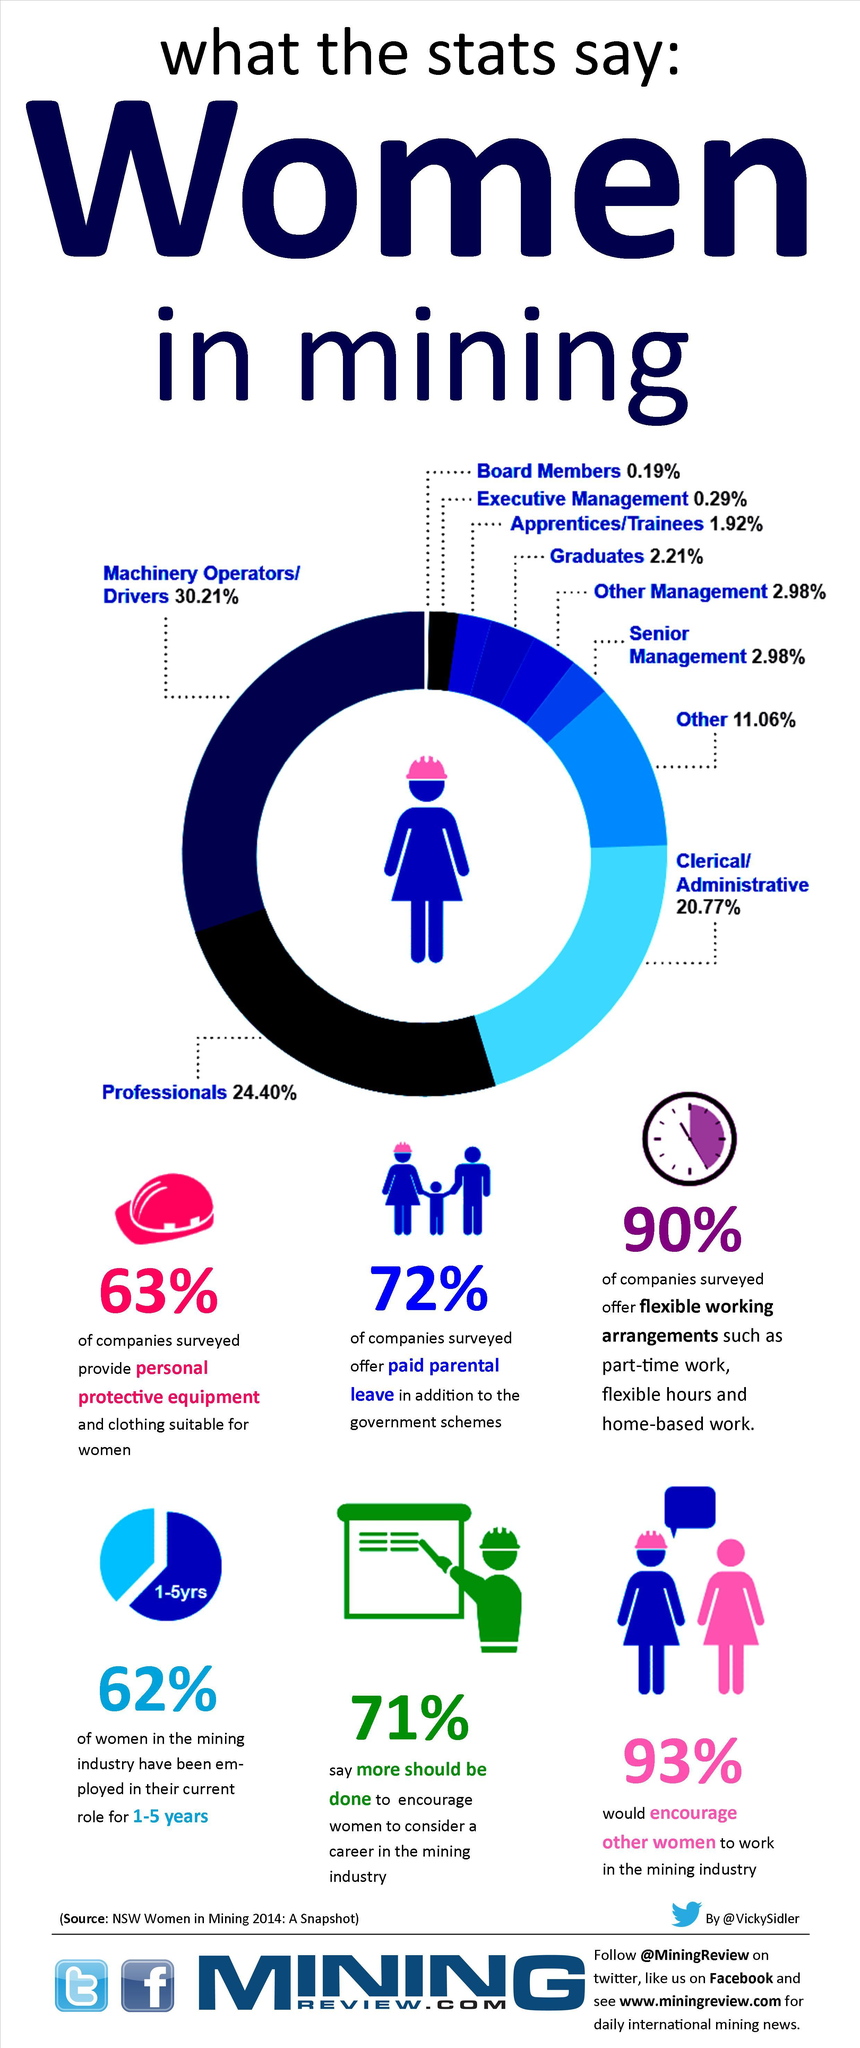List a handful of essential elements in this visual. Sixty-two percent of the women have been in the mining industry for 1 to 5 years. According to a survey of mining companies, 72% of them offered paid parental leave to their employees. A significant majority of women, or 93%, encourage other women to work in the mining industry. According to the survey, 71% of respondents believe that more effort is needed to encourage women to choose a career in the mining industry. Nine out of ten companies offered flexible work options. 